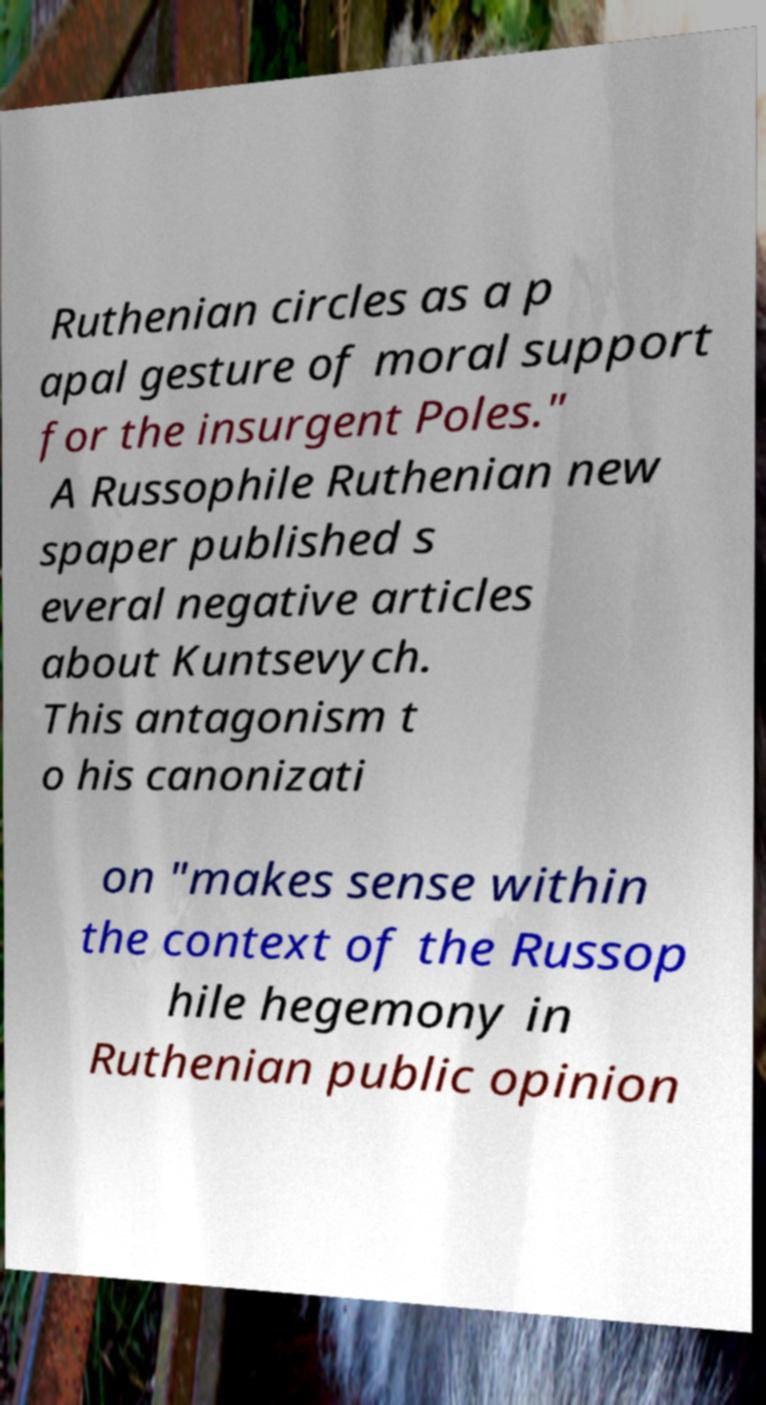What messages or text are displayed in this image? I need them in a readable, typed format. Ruthenian circles as a p apal gesture of moral support for the insurgent Poles." A Russophile Ruthenian new spaper published s everal negative articles about Kuntsevych. This antagonism t o his canonizati on "makes sense within the context of the Russop hile hegemony in Ruthenian public opinion 